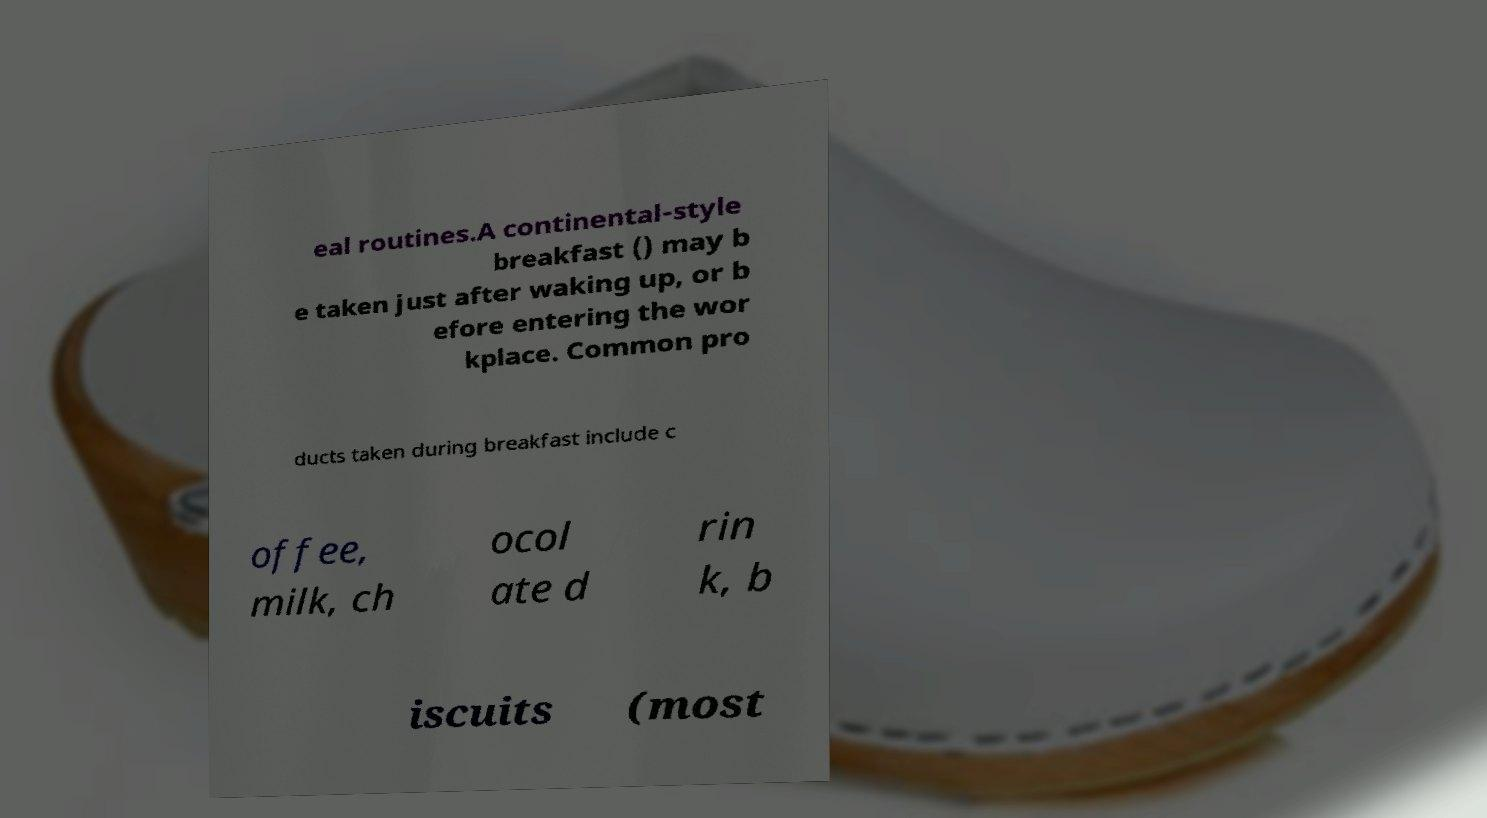Can you accurately transcribe the text from the provided image for me? eal routines.A continental-style breakfast () may b e taken just after waking up, or b efore entering the wor kplace. Common pro ducts taken during breakfast include c offee, milk, ch ocol ate d rin k, b iscuits (most 